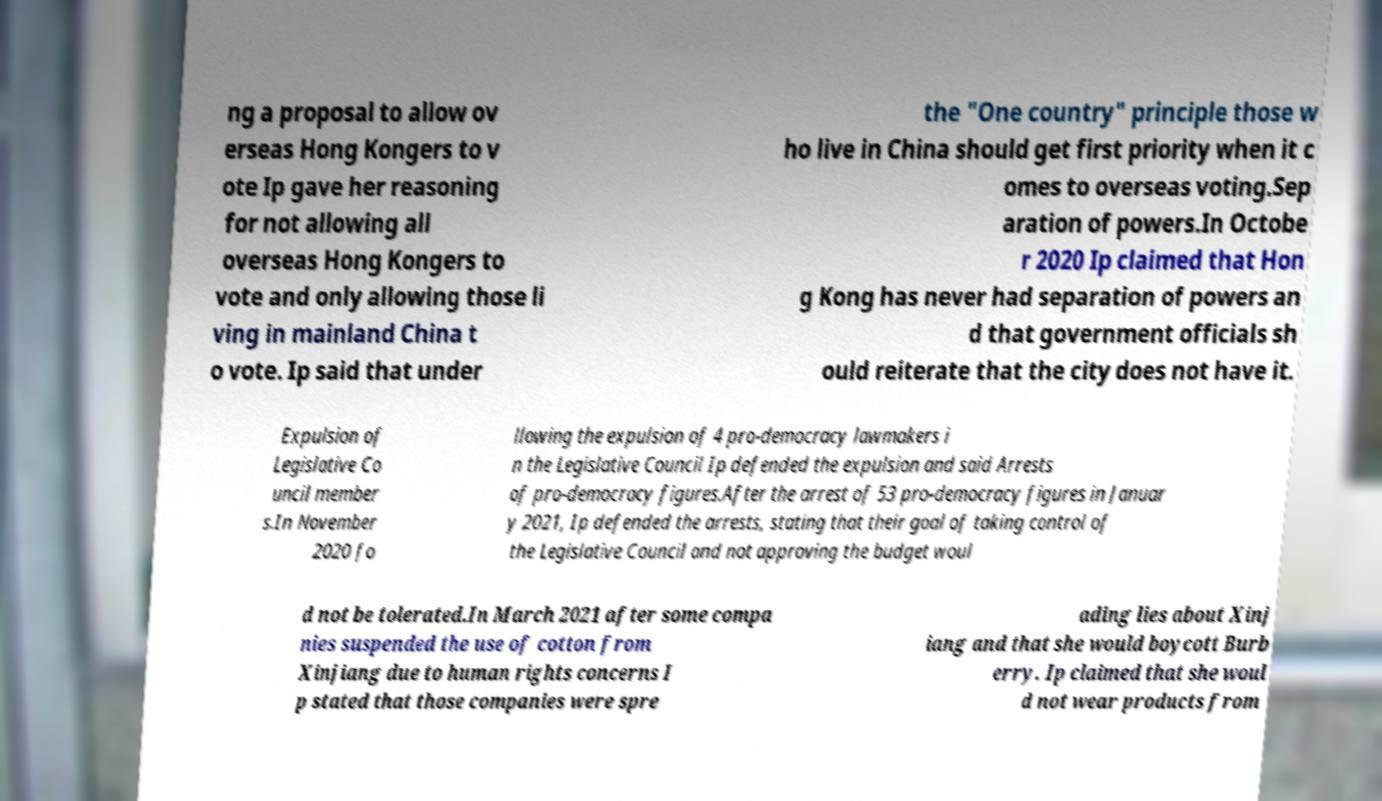There's text embedded in this image that I need extracted. Can you transcribe it verbatim? ng a proposal to allow ov erseas Hong Kongers to v ote Ip gave her reasoning for not allowing all overseas Hong Kongers to vote and only allowing those li ving in mainland China t o vote. Ip said that under the "One country" principle those w ho live in China should get first priority when it c omes to overseas voting.Sep aration of powers.In Octobe r 2020 Ip claimed that Hon g Kong has never had separation of powers an d that government officials sh ould reiterate that the city does not have it. Expulsion of Legislative Co uncil member s.In November 2020 fo llowing the expulsion of 4 pro-democracy lawmakers i n the Legislative Council Ip defended the expulsion and said Arrests of pro-democracy figures.After the arrest of 53 pro-democracy figures in Januar y 2021, Ip defended the arrests, stating that their goal of taking control of the Legislative Council and not approving the budget woul d not be tolerated.In March 2021 after some compa nies suspended the use of cotton from Xinjiang due to human rights concerns I p stated that those companies were spre ading lies about Xinj iang and that she would boycott Burb erry. Ip claimed that she woul d not wear products from 